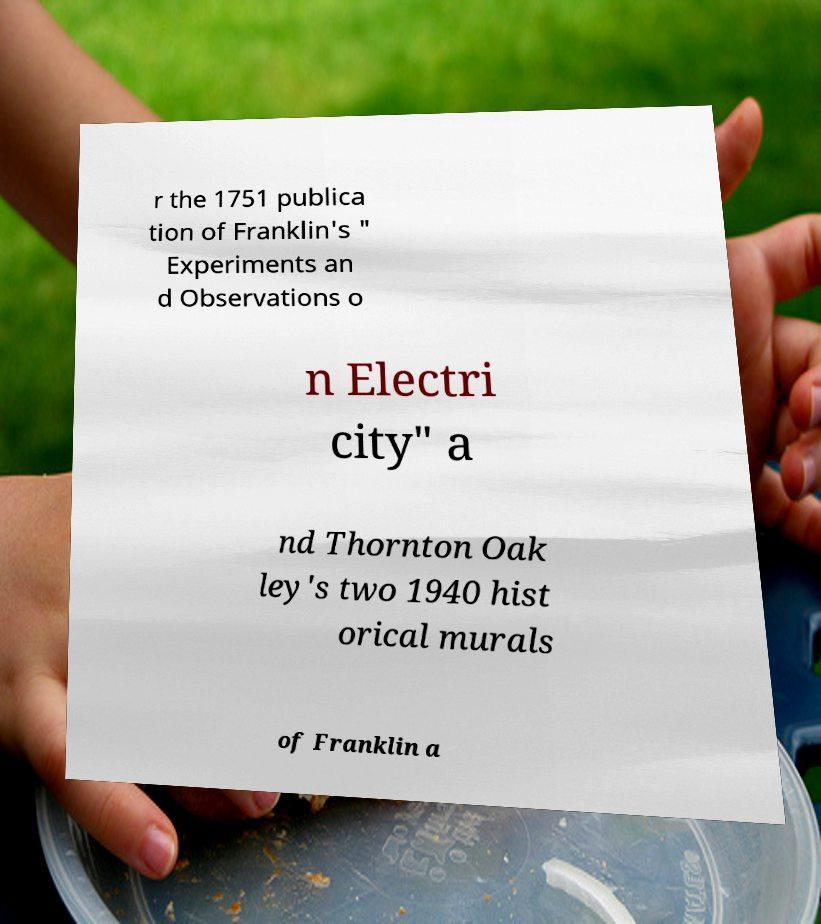Please identify and transcribe the text found in this image. r the 1751 publica tion of Franklin's " Experiments an d Observations o n Electri city" a nd Thornton Oak ley's two 1940 hist orical murals of Franklin a 